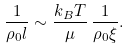<formula> <loc_0><loc_0><loc_500><loc_500>\frac { 1 } { \rho _ { 0 } l } \sim \frac { k _ { B } T } { \mu } \, \frac { 1 } { \rho _ { 0 } \xi } .</formula> 